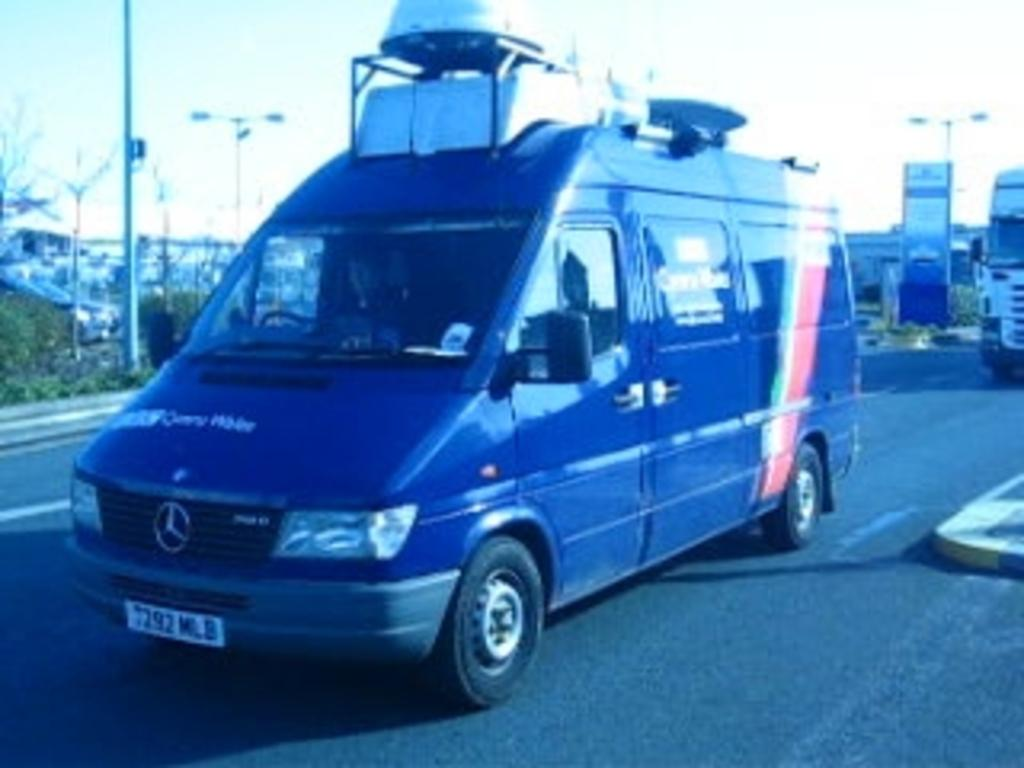<image>
Describe the image concisely. a mercedex van with cargo room on the top 